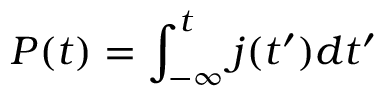Convert formula to latex. <formula><loc_0><loc_0><loc_500><loc_500>P ( t ) = \int _ { - \infty } ^ { t } j ( t ^ { \prime } ) d t ^ { \prime }</formula> 